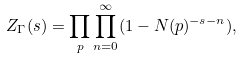Convert formula to latex. <formula><loc_0><loc_0><loc_500><loc_500>Z _ { \Gamma } ( s ) = \prod _ { p } \prod _ { n = 0 } ^ { \infty } ( 1 - N ( p ) ^ { - s - n } ) ,</formula> 